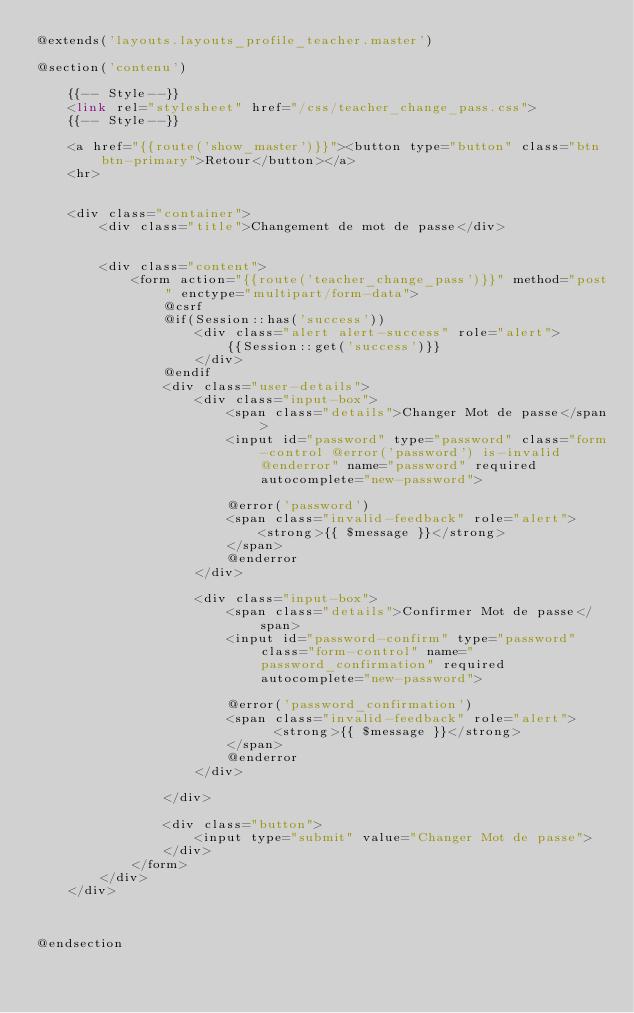<code> <loc_0><loc_0><loc_500><loc_500><_PHP_>@extends('layouts.layouts_profile_teacher.master')

@section('contenu')

    {{-- Style--}}
    <link rel="stylesheet" href="/css/teacher_change_pass.css">
    {{-- Style--}}

    <a href="{{route('show_master')}}"><button type="button" class="btn btn-primary">Retour</button></a>
    <hr>


    <div class="container">
        <div class="title">Changement de mot de passe</div>


        <div class="content">
            <form action="{{route('teacher_change_pass')}}" method="post" enctype="multipart/form-data">
                @csrf
                @if(Session::has('success'))
                    <div class="alert alert-success" role="alert">
                        {{Session::get('success')}}
                    </div>
                @endif
                <div class="user-details">
                    <div class="input-box">
                        <span class="details">Changer Mot de passe</span>
                        <input id="password" type="password" class="form-control @error('password') is-invalid @enderror" name="password" required autocomplete="new-password">

                        @error('password')
                        <span class="invalid-feedback" role="alert">
                            <strong>{{ $message }}</strong>
                        </span>
                        @enderror
                    </div>

                    <div class="input-box">
                        <span class="details">Confirmer Mot de passe</span>
                        <input id="password-confirm" type="password" class="form-control" name="password_confirmation" required autocomplete="new-password">

                        @error('password_confirmation')
                        <span class="invalid-feedback" role="alert">
                              <strong>{{ $message }}</strong>
                        </span>
                        @enderror
                    </div>

                </div>

                <div class="button">
                    <input type="submit" value="Changer Mot de passe">
                </div>
            </form>
        </div>
    </div>



@endsection
</code> 